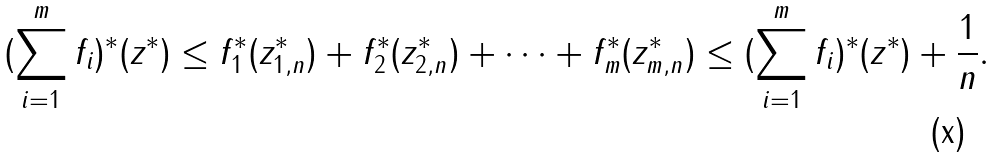<formula> <loc_0><loc_0><loc_500><loc_500>( \sum _ { i = 1 } ^ { m } f _ { i } ) ^ { * } ( z ^ { * } ) \leq f ^ { * } _ { 1 } ( z ^ { * } _ { 1 , n } ) + f ^ { * } _ { 2 } ( z ^ { * } _ { 2 , n } ) + \cdots + f ^ { * } _ { m } ( z ^ { * } _ { m , n } ) \leq ( \sum _ { i = 1 } ^ { m } f _ { i } ) ^ { * } ( z ^ { * } ) + \frac { 1 } { n } .</formula> 